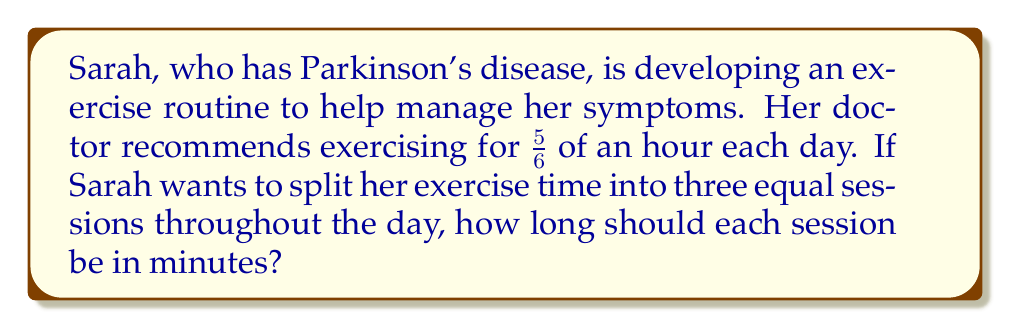Give your solution to this math problem. Let's approach this problem step-by-step:

1) First, we need to convert $\frac{5}{6}$ of an hour into minutes:
   
   $$\frac{5}{6} \text{ hour} = \frac{5}{6} \times 60 \text{ minutes}$$

2) Let's perform this multiplication:
   
   $$\frac{5}{6} \times 60 = \frac{5 \times 60}{6} = \frac{300}{6} = 50 \text{ minutes}$$

3) Now that we know the total exercise time is 50 minutes, we need to divide this into three equal sessions:
   
   $$50 \div 3 = \frac{50}{3} \approx 16.67 \text{ minutes}$$

4) Since we can't realistically measure fractions of a minute in an exercise routine, we should round this to the nearest whole number:
   
   $$16.67 \text{ minutes} \approx 17 \text{ minutes}$$

This solution allows Sarah to have three manageable exercise sessions throughout the day, which can be beneficial for someone with Parkinson's disease as it helps maintain mobility and reduces fatigue.
Answer: Each exercise session should be 17 minutes long. 